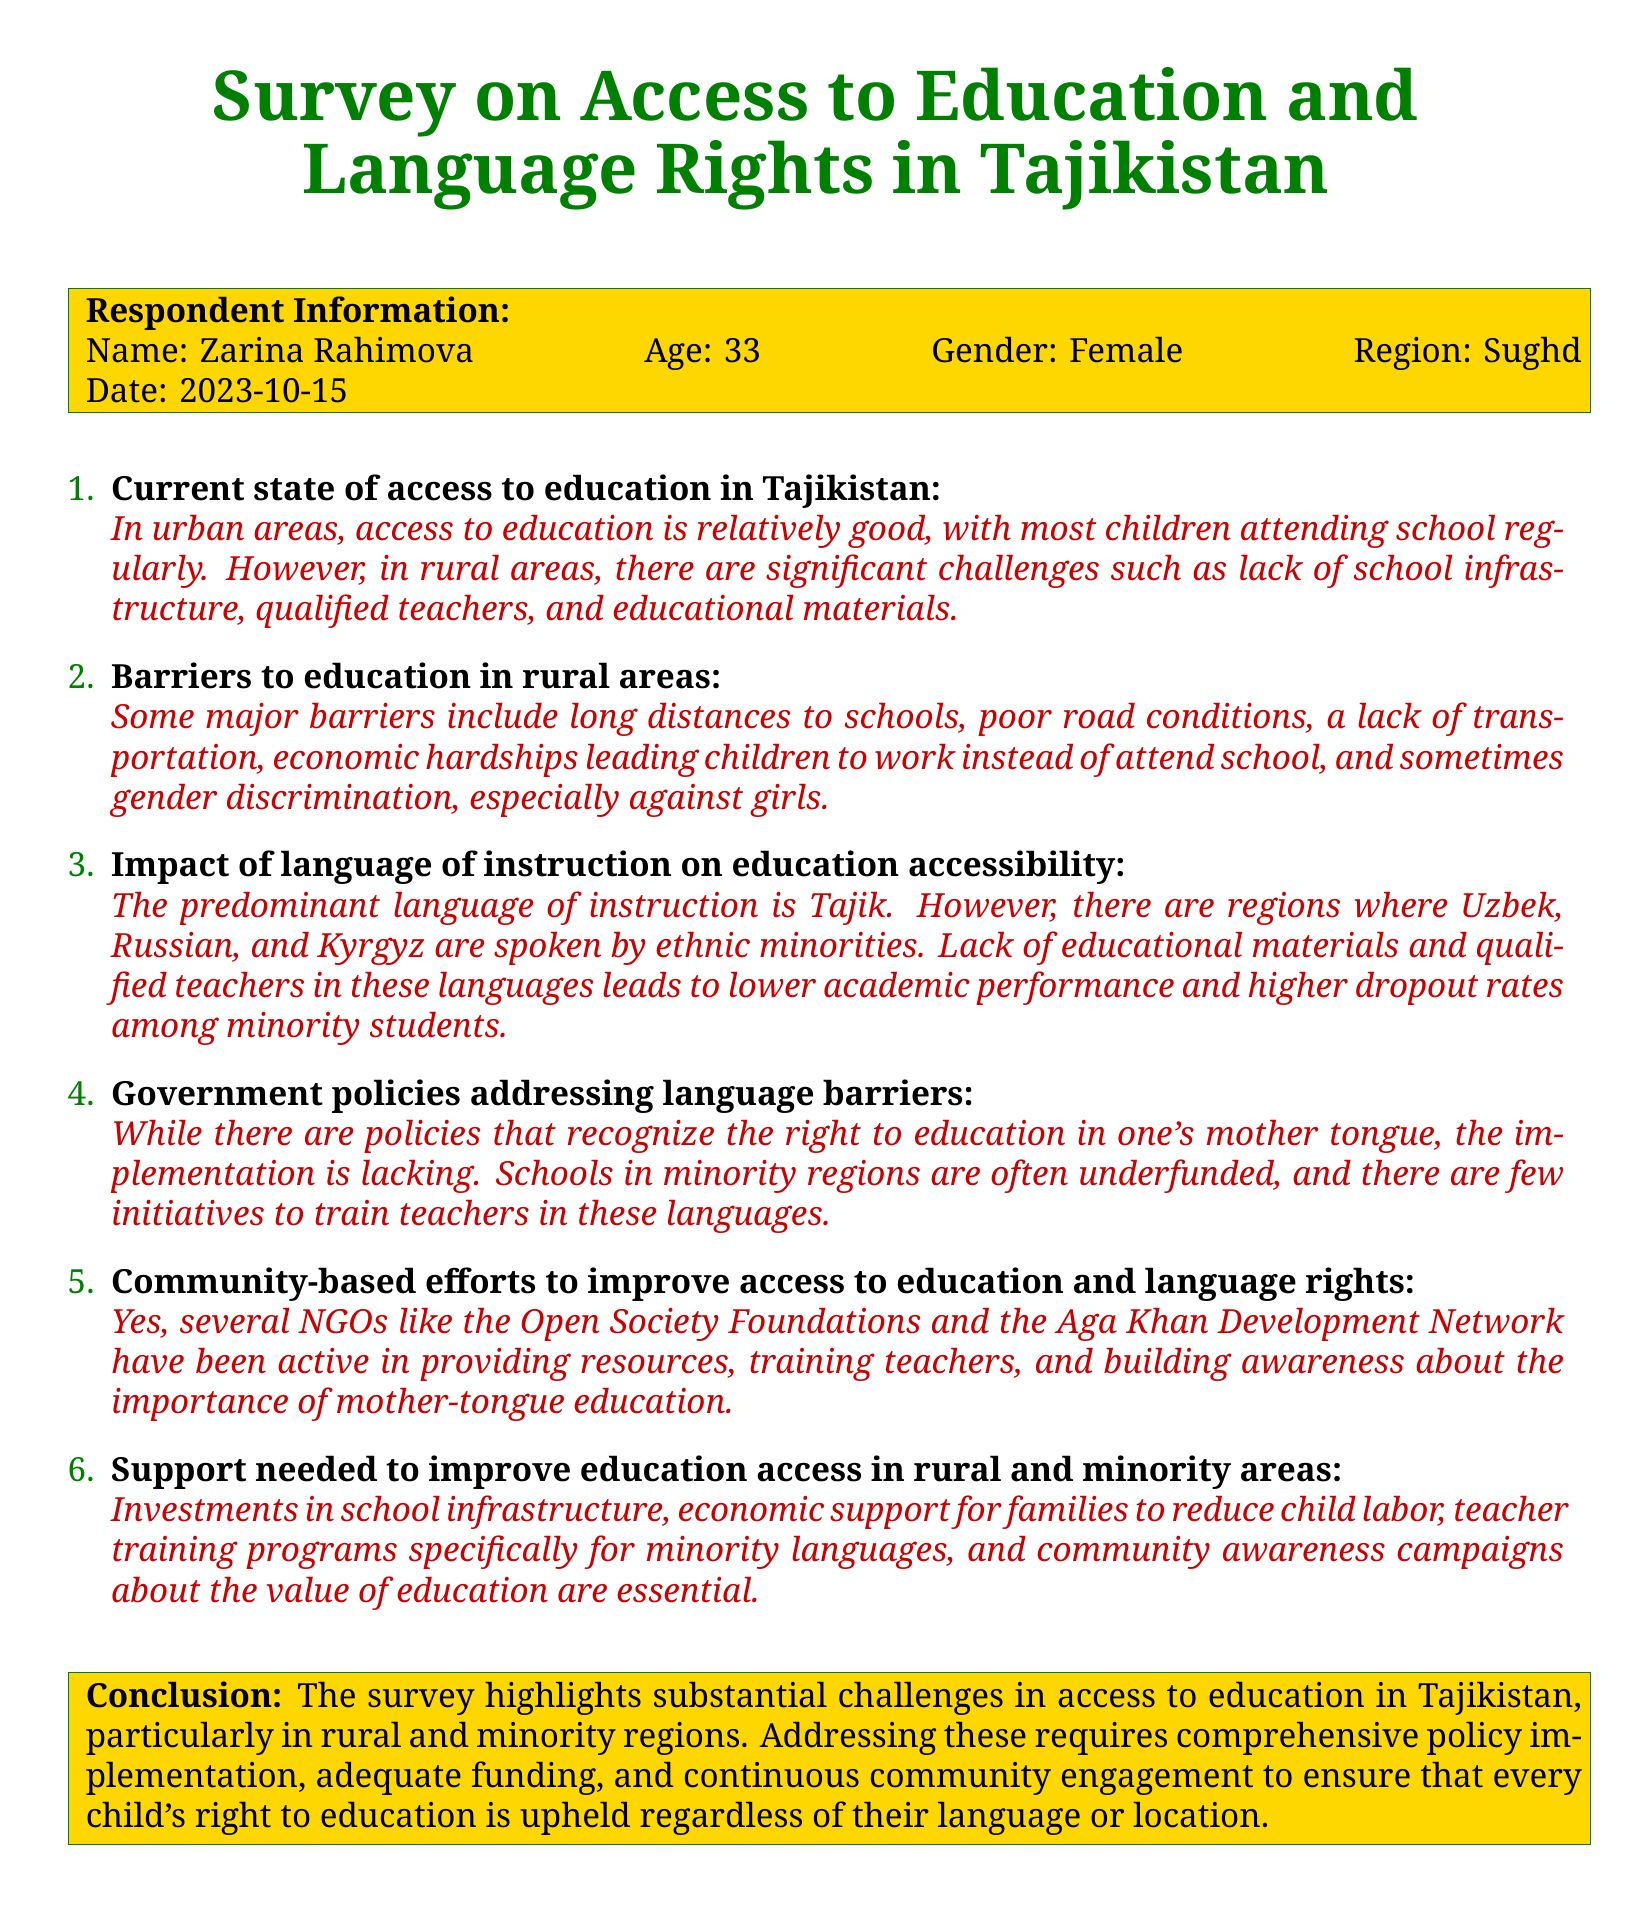what is the name of the respondent? The name of the respondent is provided in the Respondent Information section of the document.
Answer: Zarina Rahimova what is the respondent's age? The age of the respondent is included in the Respondent Information section of the document.
Answer: 33 in which region does the respondent live? The region where the respondent lives is specified in the Respondent Information section.
Answer: Sughd what is a major barrier to education mentioned for rural areas? A significant barrier is highlighted in the barriers to education section, summarizing the challenges present in rural areas.
Answer: Long distances to schools which language is predominantly used as the language of instruction? The predominant language of instruction is explicitly mentioned in the document regarding the impact of language.
Answer: Tajik what is one support needed to improve education access? The document outlines specific support needed in the section discussing support for improving education access.
Answer: Investments in school infrastructure what organization is mentioned as active in improving access to education? An organization involved in enhancing education access is mentioned in the community-based efforts section.
Answer: Open Society Foundations what date was the survey conducted? The date the survey was conducted is given in the Respondent Information section of the document.
Answer: 2023-10-15 what is the conclusion regarding access to education in Tajikistan? The conclusion summarizes the main findings of the survey regarding educational access in the country.
Answer: Substantial challenges in access to education 